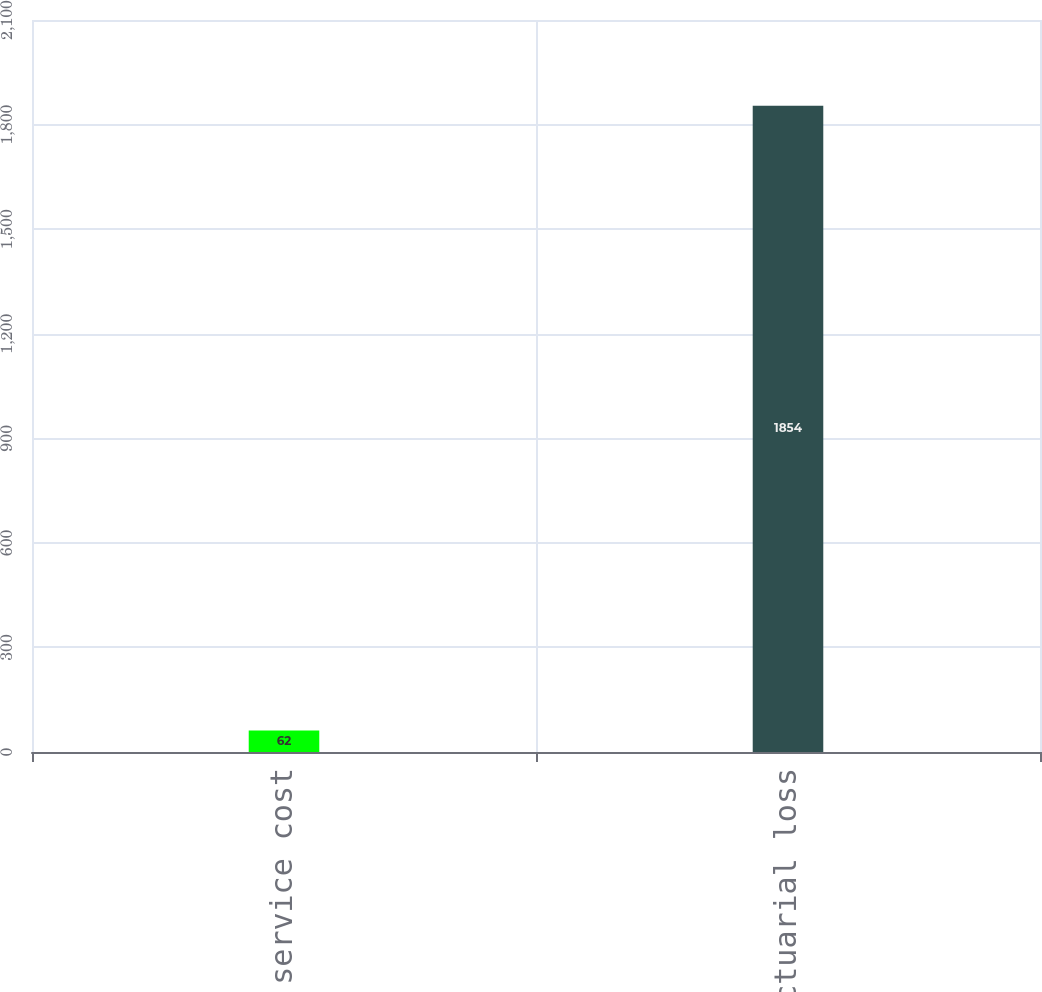Convert chart. <chart><loc_0><loc_0><loc_500><loc_500><bar_chart><fcel>Prior service cost<fcel>Net actuarial loss<nl><fcel>62<fcel>1854<nl></chart> 